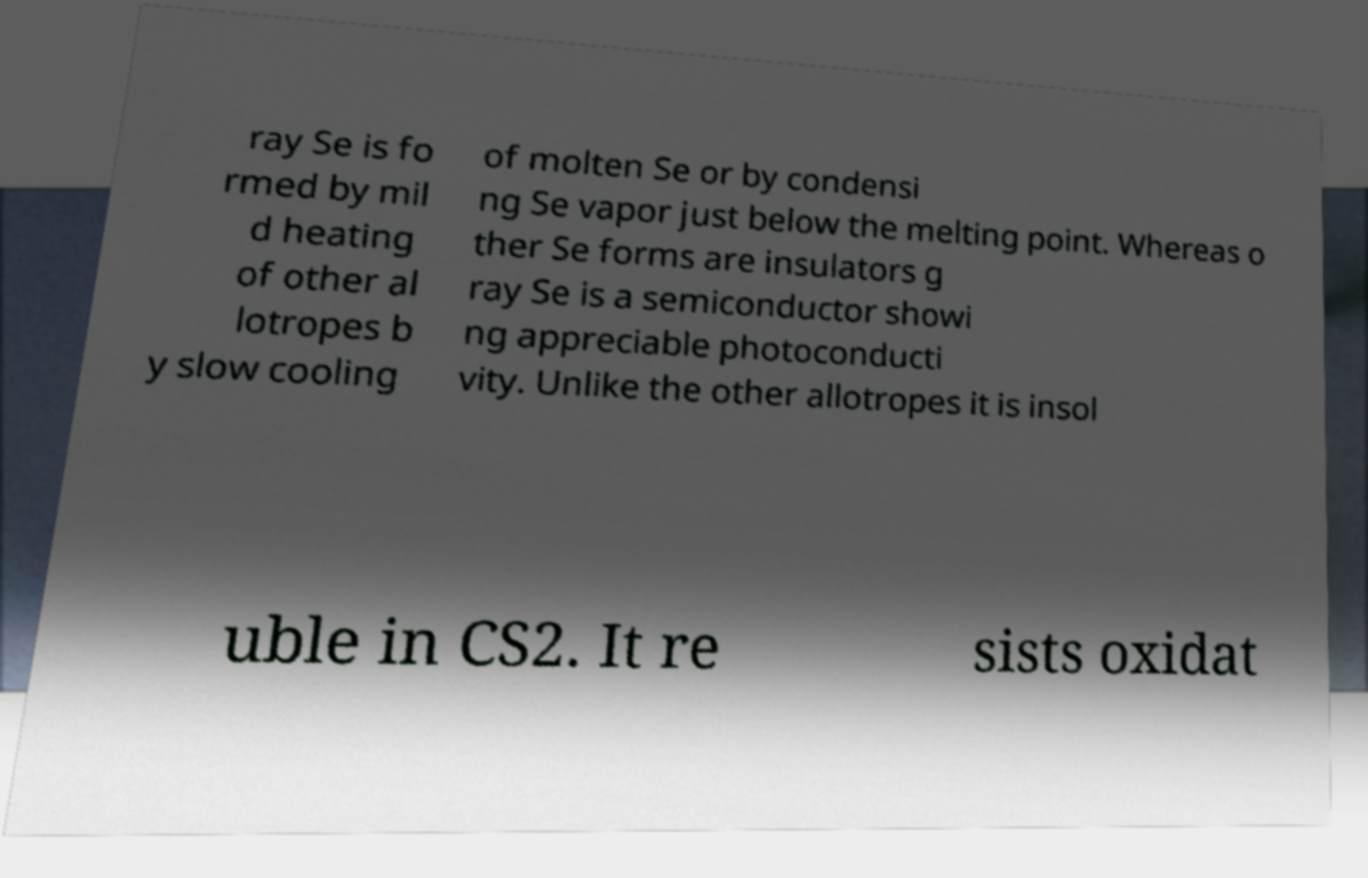There's text embedded in this image that I need extracted. Can you transcribe it verbatim? ray Se is fo rmed by mil d heating of other al lotropes b y slow cooling of molten Se or by condensi ng Se vapor just below the melting point. Whereas o ther Se forms are insulators g ray Se is a semiconductor showi ng appreciable photoconducti vity. Unlike the other allotropes it is insol uble in CS2. It re sists oxidat 